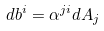<formula> <loc_0><loc_0><loc_500><loc_500>d b ^ { i } = \alpha ^ { j i } d A _ { j }</formula> 